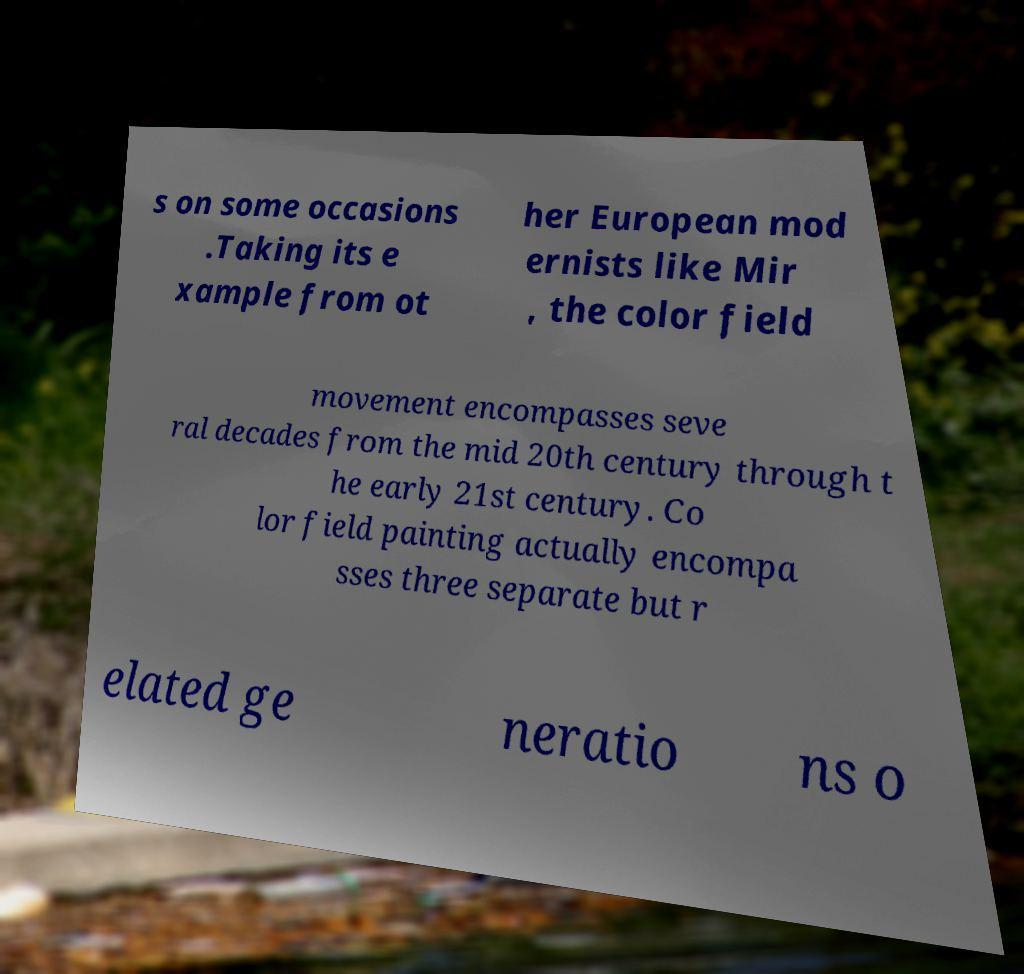I need the written content from this picture converted into text. Can you do that? s on some occasions .Taking its e xample from ot her European mod ernists like Mir , the color field movement encompasses seve ral decades from the mid 20th century through t he early 21st century. Co lor field painting actually encompa sses three separate but r elated ge neratio ns o 